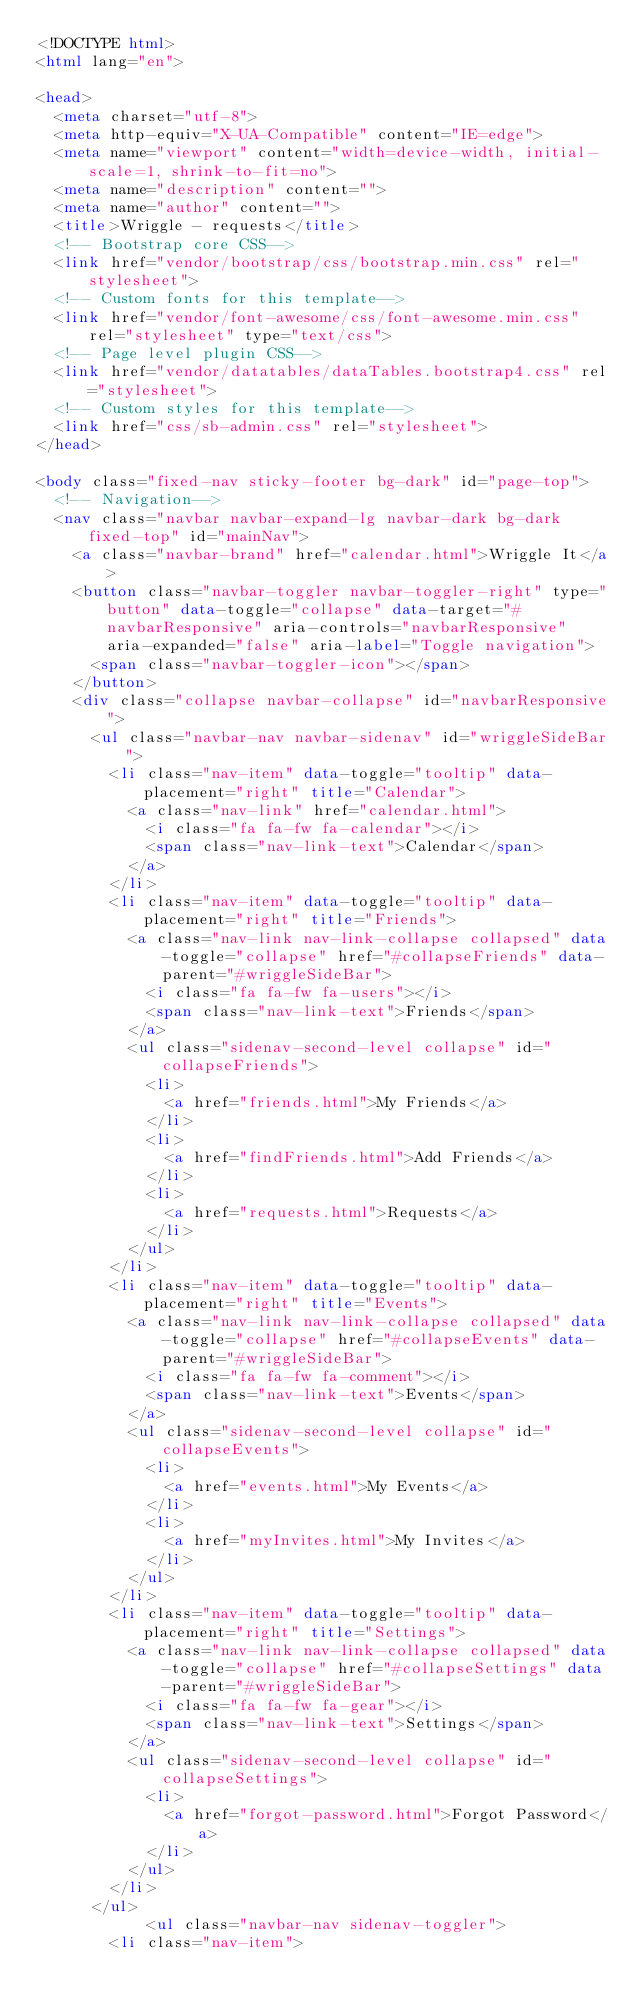Convert code to text. <code><loc_0><loc_0><loc_500><loc_500><_HTML_><!DOCTYPE html>
<html lang="en">

<head>
  <meta charset="utf-8">
  <meta http-equiv="X-UA-Compatible" content="IE=edge">
  <meta name="viewport" content="width=device-width, initial-scale=1, shrink-to-fit=no">
  <meta name="description" content="">
  <meta name="author" content="">
  <title>Wriggle - requests</title>
  <!-- Bootstrap core CSS-->
  <link href="vendor/bootstrap/css/bootstrap.min.css" rel="stylesheet">
  <!-- Custom fonts for this template-->
  <link href="vendor/font-awesome/css/font-awesome.min.css" rel="stylesheet" type="text/css">
  <!-- Page level plugin CSS-->
  <link href="vendor/datatables/dataTables.bootstrap4.css" rel="stylesheet">
  <!-- Custom styles for this template-->
  <link href="css/sb-admin.css" rel="stylesheet">
</head>

<body class="fixed-nav sticky-footer bg-dark" id="page-top">
  <!-- Navigation-->
  <nav class="navbar navbar-expand-lg navbar-dark bg-dark fixed-top" id="mainNav">
    <a class="navbar-brand" href="calendar.html">Wriggle It</a>
    <button class="navbar-toggler navbar-toggler-right" type="button" data-toggle="collapse" data-target="#navbarResponsive" aria-controls="navbarResponsive" aria-expanded="false" aria-label="Toggle navigation">
      <span class="navbar-toggler-icon"></span>
    </button>
    <div class="collapse navbar-collapse" id="navbarResponsive">
      <ul class="navbar-nav navbar-sidenav" id="wriggleSideBar">
        <li class="nav-item" data-toggle="tooltip" data-placement="right" title="Calendar">
          <a class="nav-link" href="calendar.html">
            <i class="fa fa-fw fa-calendar"></i>
            <span class="nav-link-text">Calendar</span>
          </a>
        </li>
        <li class="nav-item" data-toggle="tooltip" data-placement="right" title="Friends">
          <a class="nav-link nav-link-collapse collapsed" data-toggle="collapse" href="#collapseFriends" data-parent="#wriggleSideBar">
            <i class="fa fa-fw fa-users"></i>
            <span class="nav-link-text">Friends</span>
          </a>
          <ul class="sidenav-second-level collapse" id="collapseFriends">
            <li>
              <a href="friends.html">My Friends</a>
            </li>
            <li>
              <a href="findFriends.html">Add Friends</a>
            </li>
            <li>
              <a href="requests.html">Requests</a>
            </li>
          </ul>
        </li>
        <li class="nav-item" data-toggle="tooltip" data-placement="right" title="Events">
          <a class="nav-link nav-link-collapse collapsed" data-toggle="collapse" href="#collapseEvents" data-parent="#wriggleSideBar">
            <i class="fa fa-fw fa-comment"></i>
            <span class="nav-link-text">Events</span>
          </a>
          <ul class="sidenav-second-level collapse" id="collapseEvents">
            <li>
              <a href="events.html">My Events</a>
            </li>
            <li>
              <a href="myInvites.html">My Invites</a>
            </li>
          </ul>
        </li>
        <li class="nav-item" data-toggle="tooltip" data-placement="right" title="Settings">
          <a class="nav-link nav-link-collapse collapsed" data-toggle="collapse" href="#collapseSettings" data-parent="#wriggleSideBar">
            <i class="fa fa-fw fa-gear"></i>
            <span class="nav-link-text">Settings</span>
          </a>
          <ul class="sidenav-second-level collapse" id="collapseSettings">
            <li>
              <a href="forgot-password.html">Forgot Password</a>
            </li>
          </ul>
        </li>
      </ul>
            <ul class="navbar-nav sidenav-toggler">
        <li class="nav-item"></code> 